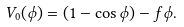<formula> <loc_0><loc_0><loc_500><loc_500>V _ { 0 } ( \phi ) = ( 1 - \cos \phi ) - f \phi .</formula> 